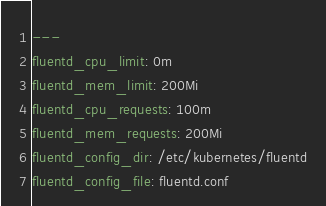Convert code to text. <code><loc_0><loc_0><loc_500><loc_500><_YAML_>---
fluentd_cpu_limit: 0m
fluentd_mem_limit: 200Mi
fluentd_cpu_requests: 100m
fluentd_mem_requests: 200Mi
fluentd_config_dir: /etc/kubernetes/fluentd
fluentd_config_file: fluentd.conf
</code> 